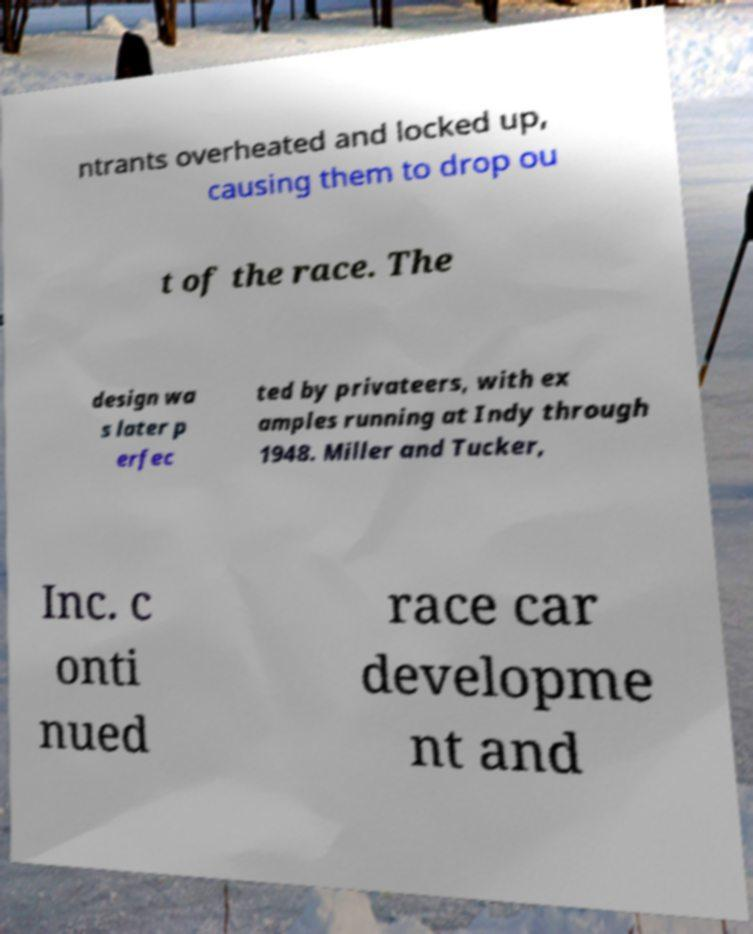Please identify and transcribe the text found in this image. ntrants overheated and locked up, causing them to drop ou t of the race. The design wa s later p erfec ted by privateers, with ex amples running at Indy through 1948. Miller and Tucker, Inc. c onti nued race car developme nt and 